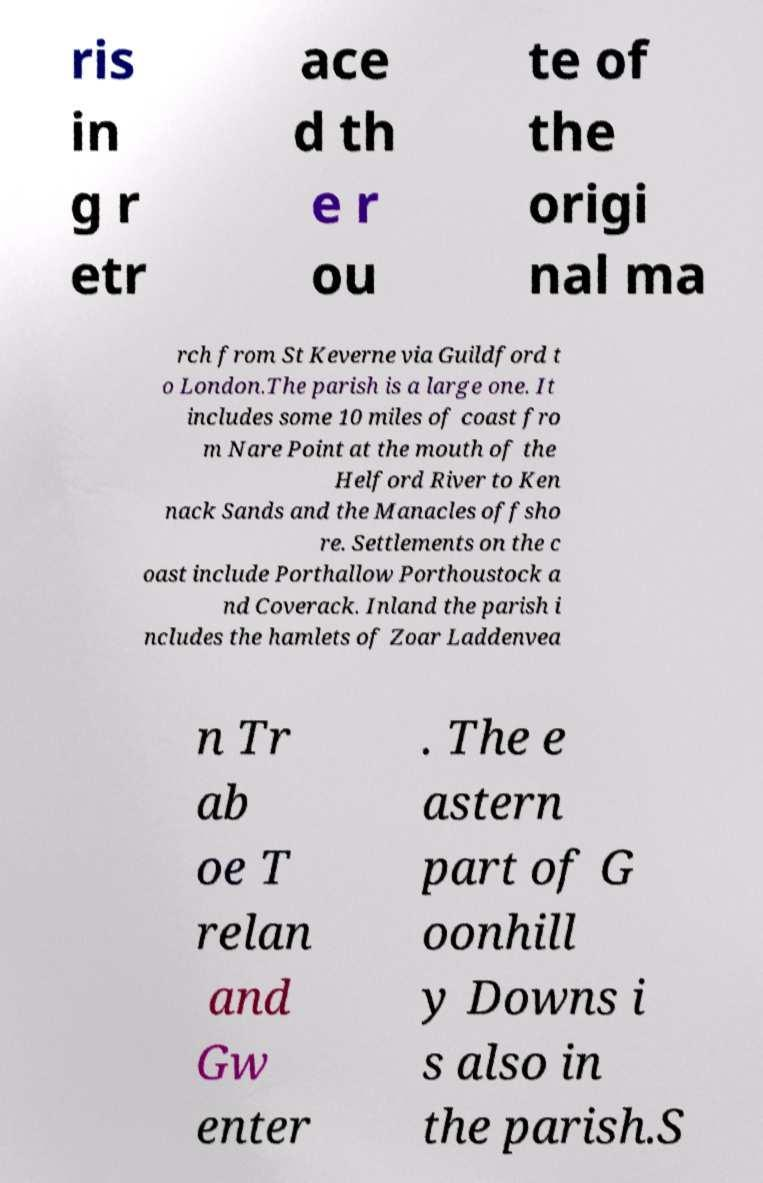What messages or text are displayed in this image? I need them in a readable, typed format. ris in g r etr ace d th e r ou te of the origi nal ma rch from St Keverne via Guildford t o London.The parish is a large one. It includes some 10 miles of coast fro m Nare Point at the mouth of the Helford River to Ken nack Sands and the Manacles offsho re. Settlements on the c oast include Porthallow Porthoustock a nd Coverack. Inland the parish i ncludes the hamlets of Zoar Laddenvea n Tr ab oe T relan and Gw enter . The e astern part of G oonhill y Downs i s also in the parish.S 